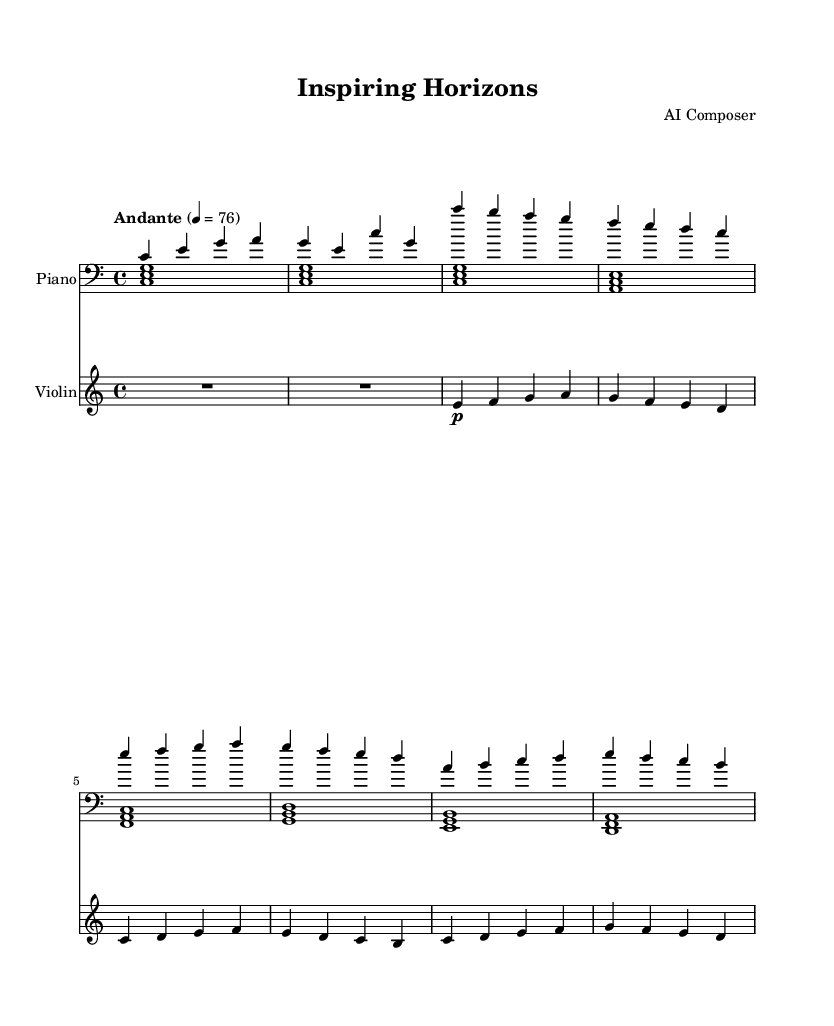What is the key signature of this music? The key signature is C major, which is indicated by the absence of any sharps or flats in the staff.
Answer: C major What is the time signature of the piece? The time signature is indicated at the beginning of the score as four beats per measure, shown as 4/4.
Answer: 4/4 What is the tempo marking for this music? The tempo marking is "Andante," which suggests a moderately slow tempo. It indicates the speed at which the music should be played.
Answer: Andante What instruments are featured in the score? The score features a piano and a violin, as indicated at the start of each staff.
Answer: Piano and Violin How many measures are in the main theme section? Counting the measures of the main theme presented by both instruments, there are a total of six measures in the main theme.
Answer: Six measures Which instrument carries the melody primarily? The violin carries the melody primarily, as it plays the more prominent and lyrical line compared to the piano which provides harmony and support.
Answer: Violin What figure is utilized in the left-hand part of the piano score? The left hand of the piano part consistently utilizes broken chords, indicated by the simultaneous playing of three notes in a repeating pattern.
Answer: Broken chords 